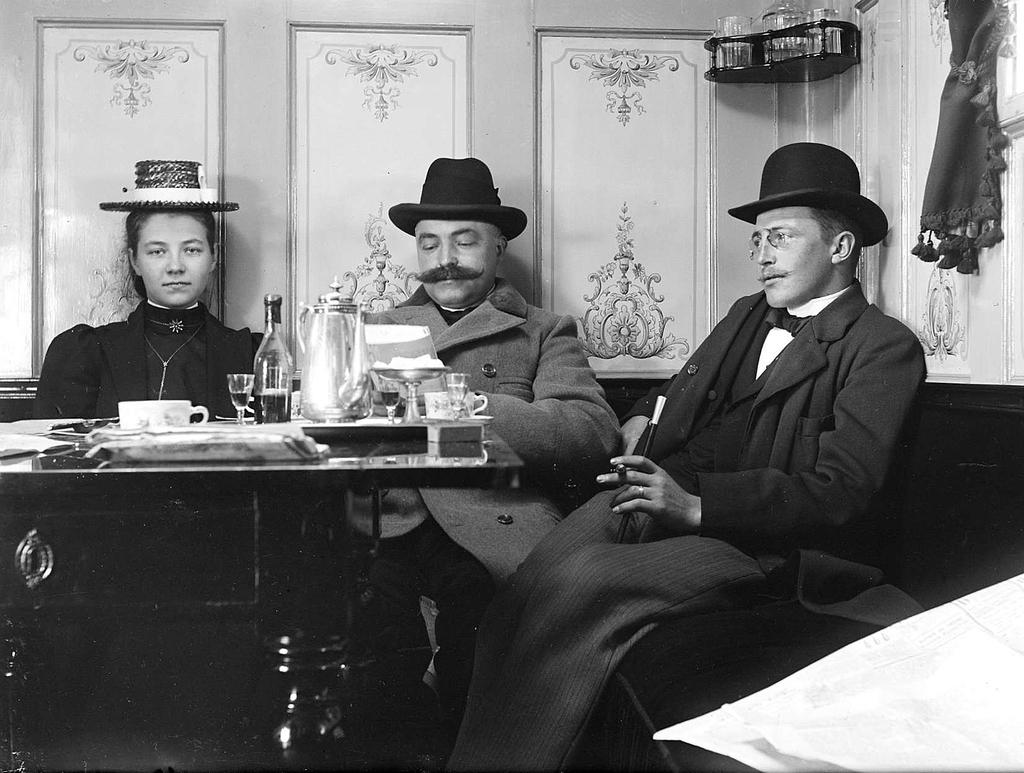How many people are in the image? There are three persons in the image. What are the persons wearing on their heads? The persons are wearing hats. What are the persons doing in the image? The persons are having drinks and have eatable items. What can be seen in the background of the image? There is a wall in the background of the image. What type of fang can be seen in the image? There are no fangs present in the image. Can you tell me how many cameras are visible in the image? There are no cameras visible in the image. 